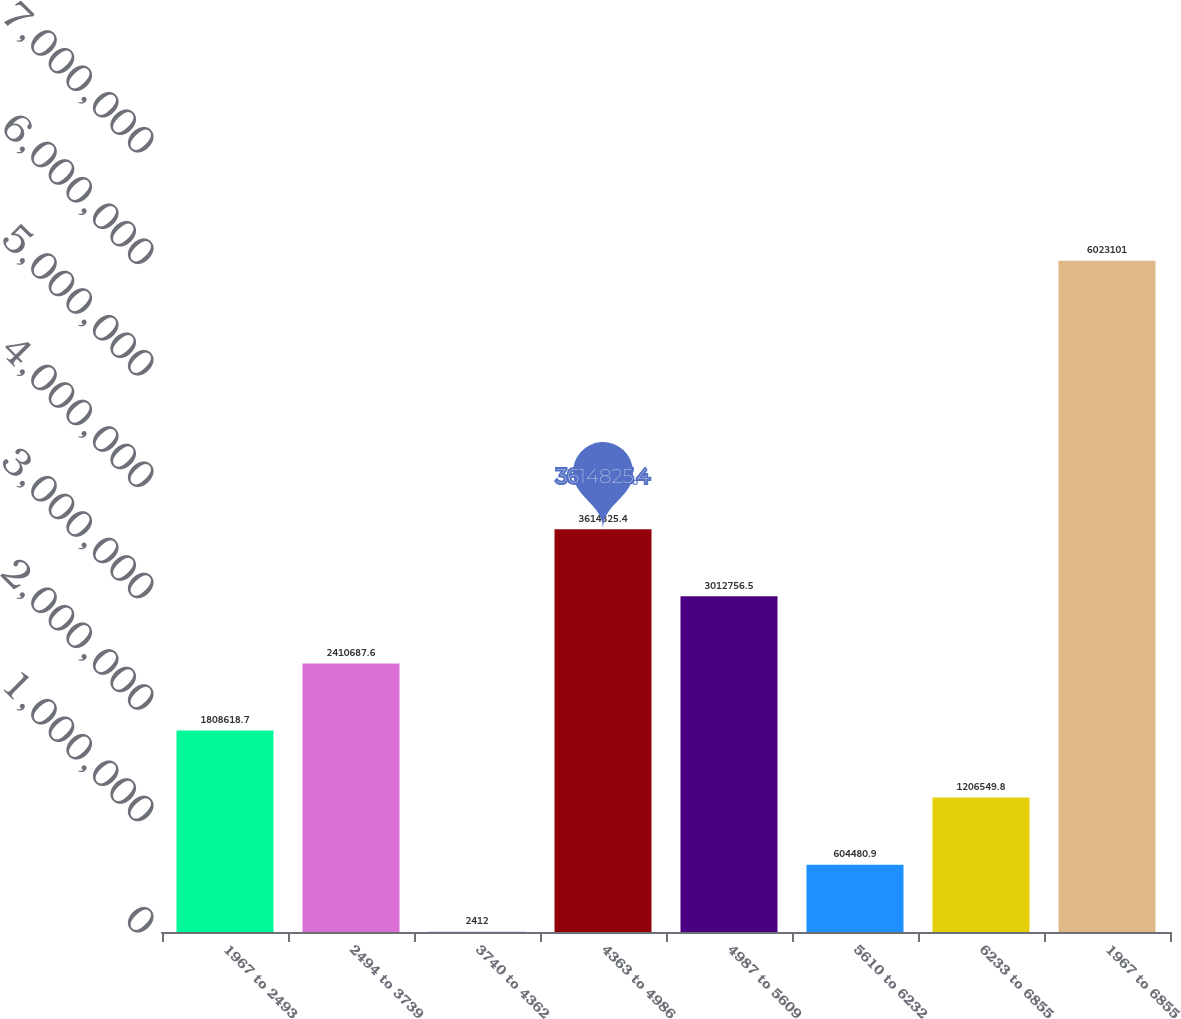<chart> <loc_0><loc_0><loc_500><loc_500><bar_chart><fcel>1967 to 2493<fcel>2494 to 3739<fcel>3740 to 4362<fcel>4363 to 4986<fcel>4987 to 5609<fcel>5610 to 6232<fcel>6233 to 6855<fcel>1967 to 6855<nl><fcel>1.80862e+06<fcel>2.41069e+06<fcel>2412<fcel>3.61483e+06<fcel>3.01276e+06<fcel>604481<fcel>1.20655e+06<fcel>6.0231e+06<nl></chart> 